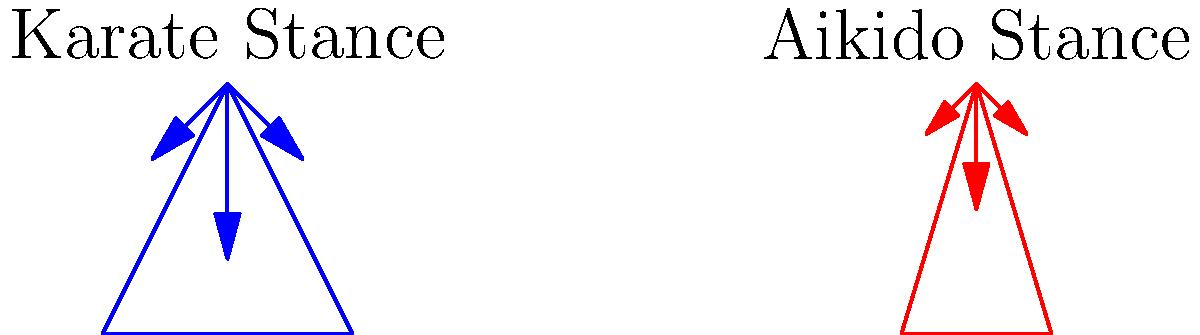Compare the force distribution in the Karate and Aikido stances shown in the diagram. Which stance provides better stability and why? To compare the force distribution and stability of the Karate and Aikido stances, we need to analyze several factors:

1. Stance width:
   - Karate stance: Wider foot placement
   - Aikido stance: Narrower foot placement

2. Center of gravity:
   - Both stances have a lowered center of gravity, but the Karate stance appears lower

3. Force vectors:
   - Karate stance: 
     * Stronger downward force (longer vertical arrow)
     * Wider lateral forces (arrows pointing diagonally outward)
   - Aikido stance:
     * Moderate downward force (shorter vertical arrow)
     * Narrower lateral forces (arrows pointing diagonally outward)

4. Stability analysis:
   - Wider stance (Karate) provides a larger base of support, increasing lateral stability
   - Lower center of gravity (Karate) improves overall stability
   - Stronger downward force (Karate) enhances grounding and resistance to being moved

5. Flexibility and adaptability:
   - Narrower stance (Aikido) allows for quicker movement and transitions
   - Higher center of gravity (Aikido) facilitates easier weight shifts

Considering these factors, the Karate stance provides better stability due to its wider base, lower center of gravity, and stronger downward force. However, the Aikido stance offers more flexibility for quick movements, which can be advantageous in certain situations.
Answer: Karate stance provides better stability due to wider base, lower center of gravity, and stronger grounding force. 